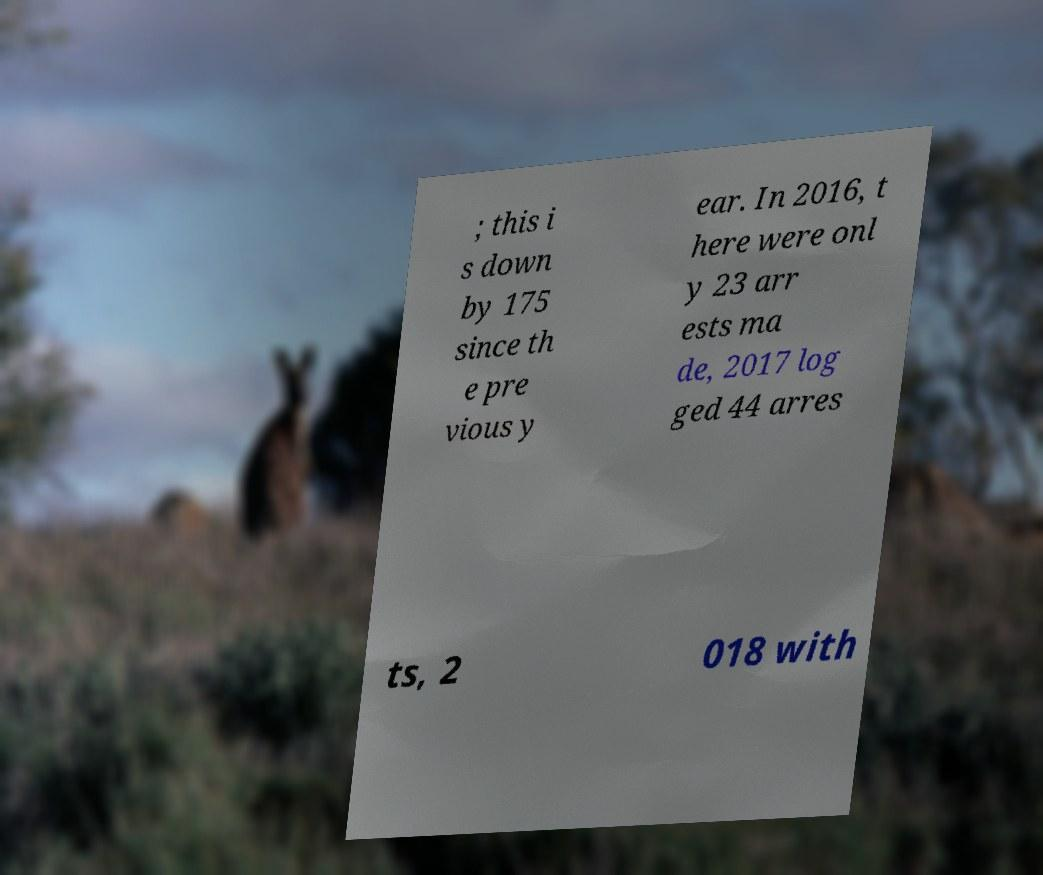Can you read and provide the text displayed in the image?This photo seems to have some interesting text. Can you extract and type it out for me? ; this i s down by 175 since th e pre vious y ear. In 2016, t here were onl y 23 arr ests ma de, 2017 log ged 44 arres ts, 2 018 with 